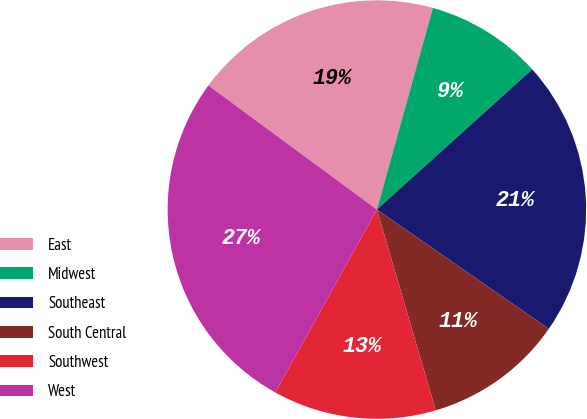Convert chart. <chart><loc_0><loc_0><loc_500><loc_500><pie_chart><fcel>East<fcel>Midwest<fcel>Southeast<fcel>South Central<fcel>Southwest<fcel>West<nl><fcel>19.21%<fcel>9.0%<fcel>21.34%<fcel>10.81%<fcel>12.61%<fcel>27.03%<nl></chart> 